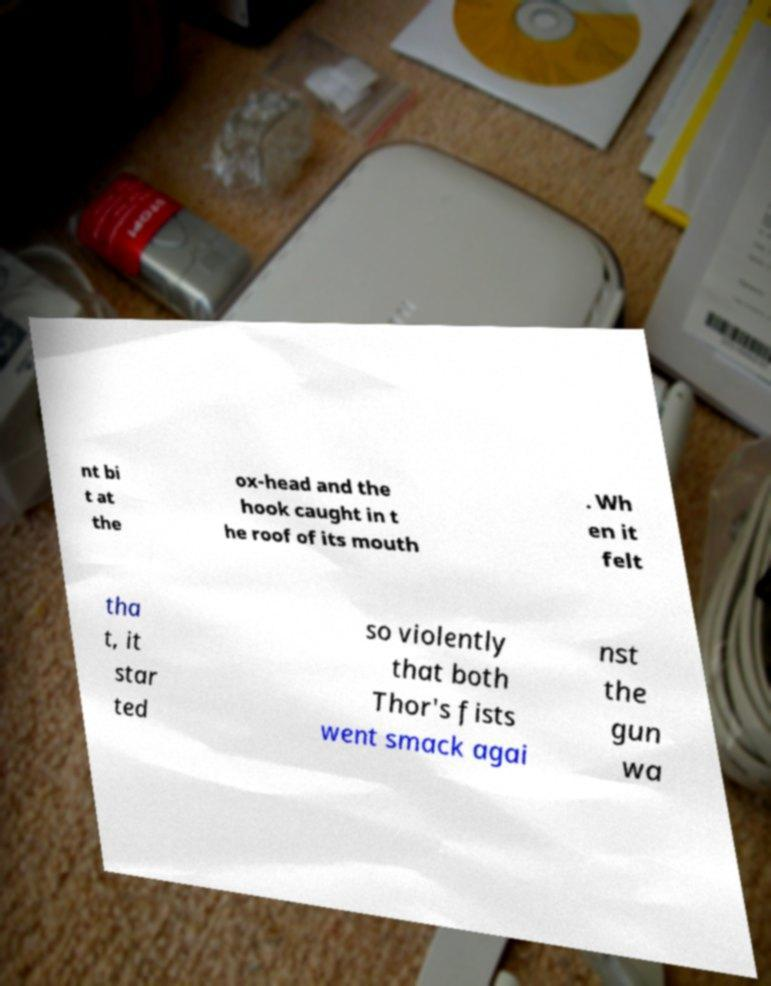What messages or text are displayed in this image? I need them in a readable, typed format. nt bi t at the ox-head and the hook caught in t he roof of its mouth . Wh en it felt tha t, it star ted so violently that both Thor's fists went smack agai nst the gun wa 